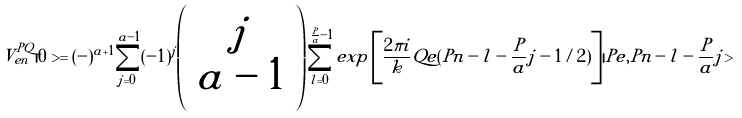Convert formula to latex. <formula><loc_0><loc_0><loc_500><loc_500>V _ { e n } ^ { P Q } | 0 > = ( - ) ^ { a + 1 } \sum _ { j = 0 } ^ { a - 1 } ( - 1 ) ^ { j } \left ( \begin{array} { c } j \\ a - 1 \end{array} \right ) \sum _ { l = 0 } ^ { \frac { P } { a } - 1 } e x p \left [ \frac { 2 \pi i } { k } Q e ( P n - l - \frac { P } { a } j - 1 / 2 ) \right ] | P e , P n - l - \frac { P } { a } j ></formula> 